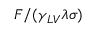Convert formula to latex. <formula><loc_0><loc_0><loc_500><loc_500>F / ( \gamma _ { L V } \lambda \sigma )</formula> 